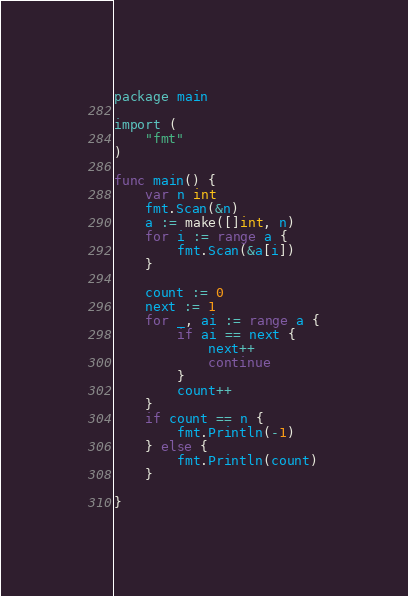<code> <loc_0><loc_0><loc_500><loc_500><_Go_>package main

import (
	"fmt"
)

func main() {
	var n int
	fmt.Scan(&n)
	a := make([]int, n)
	for i := range a {
		fmt.Scan(&a[i])
	}

	count := 0
	next := 1
	for _, ai := range a {
		if ai == next {
			next++
			continue
		}
		count++
	}
	if count == n {
		fmt.Println(-1)
	} else {
		fmt.Println(count)
	}

}
</code> 